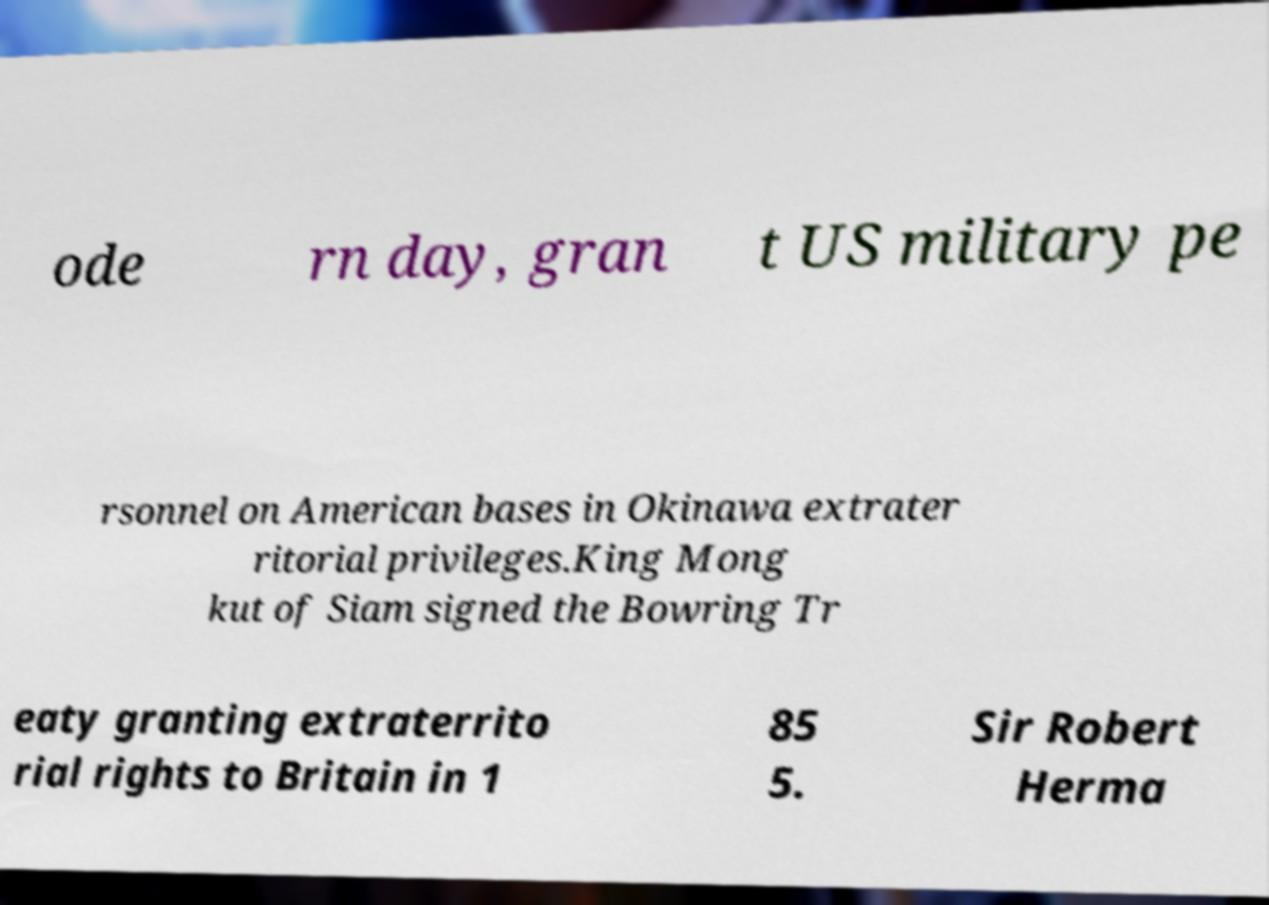Please read and relay the text visible in this image. What does it say? ode rn day, gran t US military pe rsonnel on American bases in Okinawa extrater ritorial privileges.King Mong kut of Siam signed the Bowring Tr eaty granting extraterrito rial rights to Britain in 1 85 5. Sir Robert Herma 